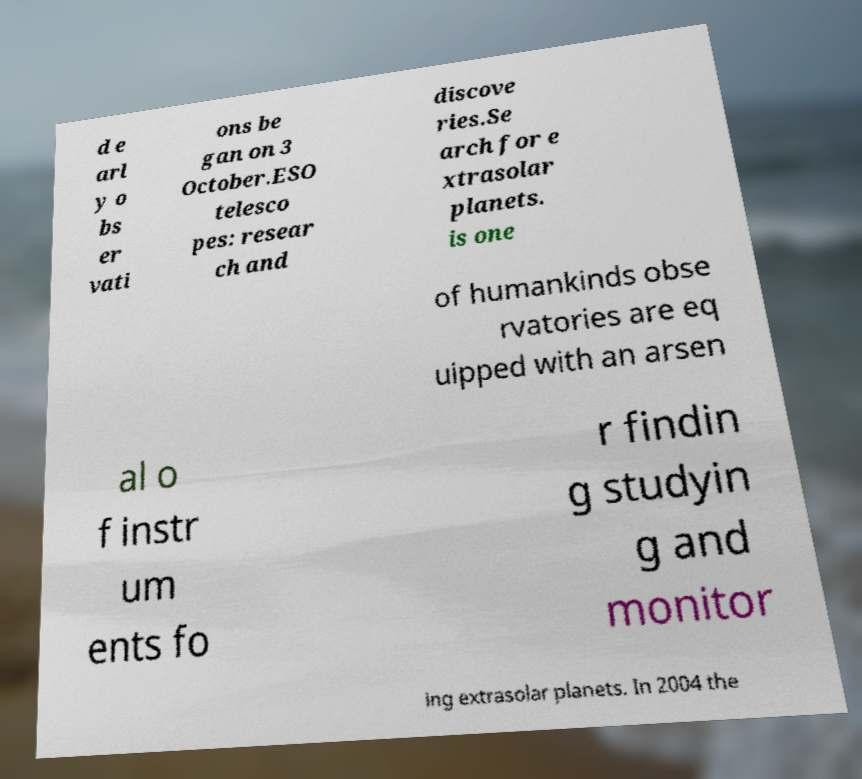Please identify and transcribe the text found in this image. d e arl y o bs er vati ons be gan on 3 October.ESO telesco pes: resear ch and discove ries.Se arch for e xtrasolar planets. is one of humankinds obse rvatories are eq uipped with an arsen al o f instr um ents fo r findin g studyin g and monitor ing extrasolar planets. In 2004 the 